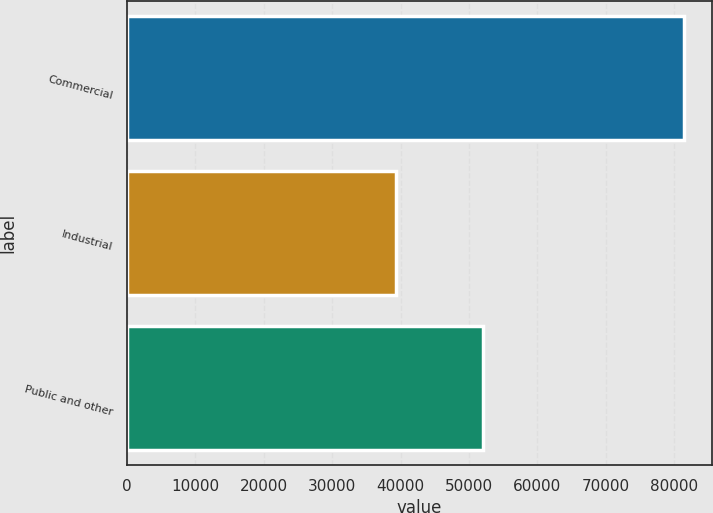Convert chart to OTSL. <chart><loc_0><loc_0><loc_500><loc_500><bar_chart><fcel>Commercial<fcel>Industrial<fcel>Public and other<nl><fcel>81455<fcel>39295<fcel>52069<nl></chart> 